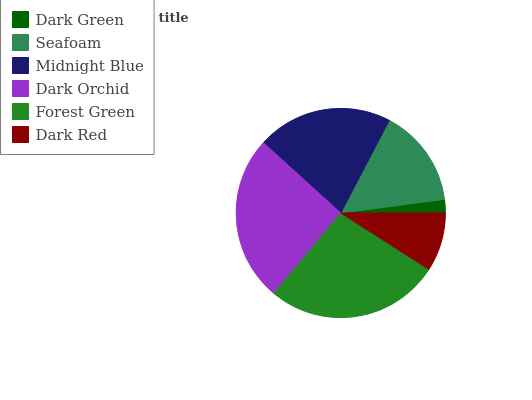Is Dark Green the minimum?
Answer yes or no. Yes. Is Forest Green the maximum?
Answer yes or no. Yes. Is Seafoam the minimum?
Answer yes or no. No. Is Seafoam the maximum?
Answer yes or no. No. Is Seafoam greater than Dark Green?
Answer yes or no. Yes. Is Dark Green less than Seafoam?
Answer yes or no. Yes. Is Dark Green greater than Seafoam?
Answer yes or no. No. Is Seafoam less than Dark Green?
Answer yes or no. No. Is Midnight Blue the high median?
Answer yes or no. Yes. Is Seafoam the low median?
Answer yes or no. Yes. Is Seafoam the high median?
Answer yes or no. No. Is Dark Orchid the low median?
Answer yes or no. No. 